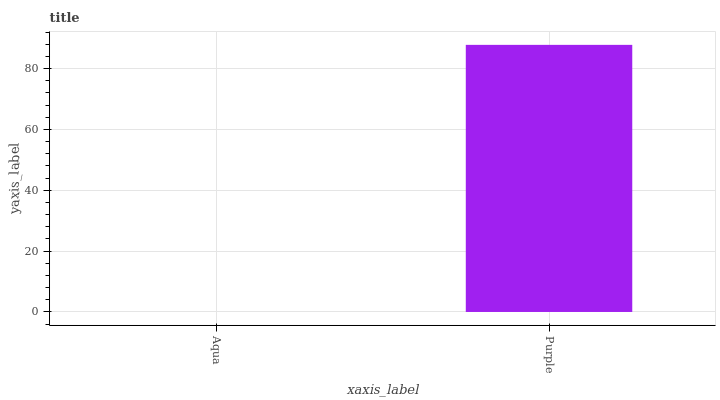Is Aqua the minimum?
Answer yes or no. Yes. Is Purple the maximum?
Answer yes or no. Yes. Is Purple the minimum?
Answer yes or no. No. Is Purple greater than Aqua?
Answer yes or no. Yes. Is Aqua less than Purple?
Answer yes or no. Yes. Is Aqua greater than Purple?
Answer yes or no. No. Is Purple less than Aqua?
Answer yes or no. No. Is Purple the high median?
Answer yes or no. Yes. Is Aqua the low median?
Answer yes or no. Yes. Is Aqua the high median?
Answer yes or no. No. Is Purple the low median?
Answer yes or no. No. 